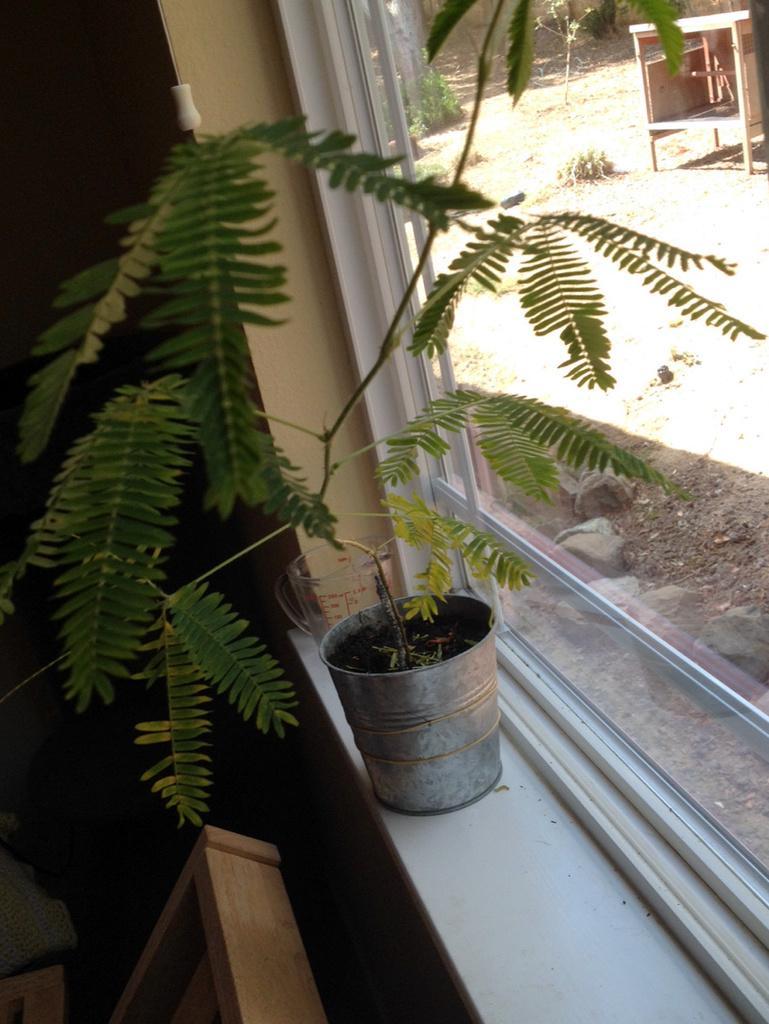Please provide a concise description of this image. This picture shows up a window of a house. We see a plant in the pot and we see a wooden box on the side 